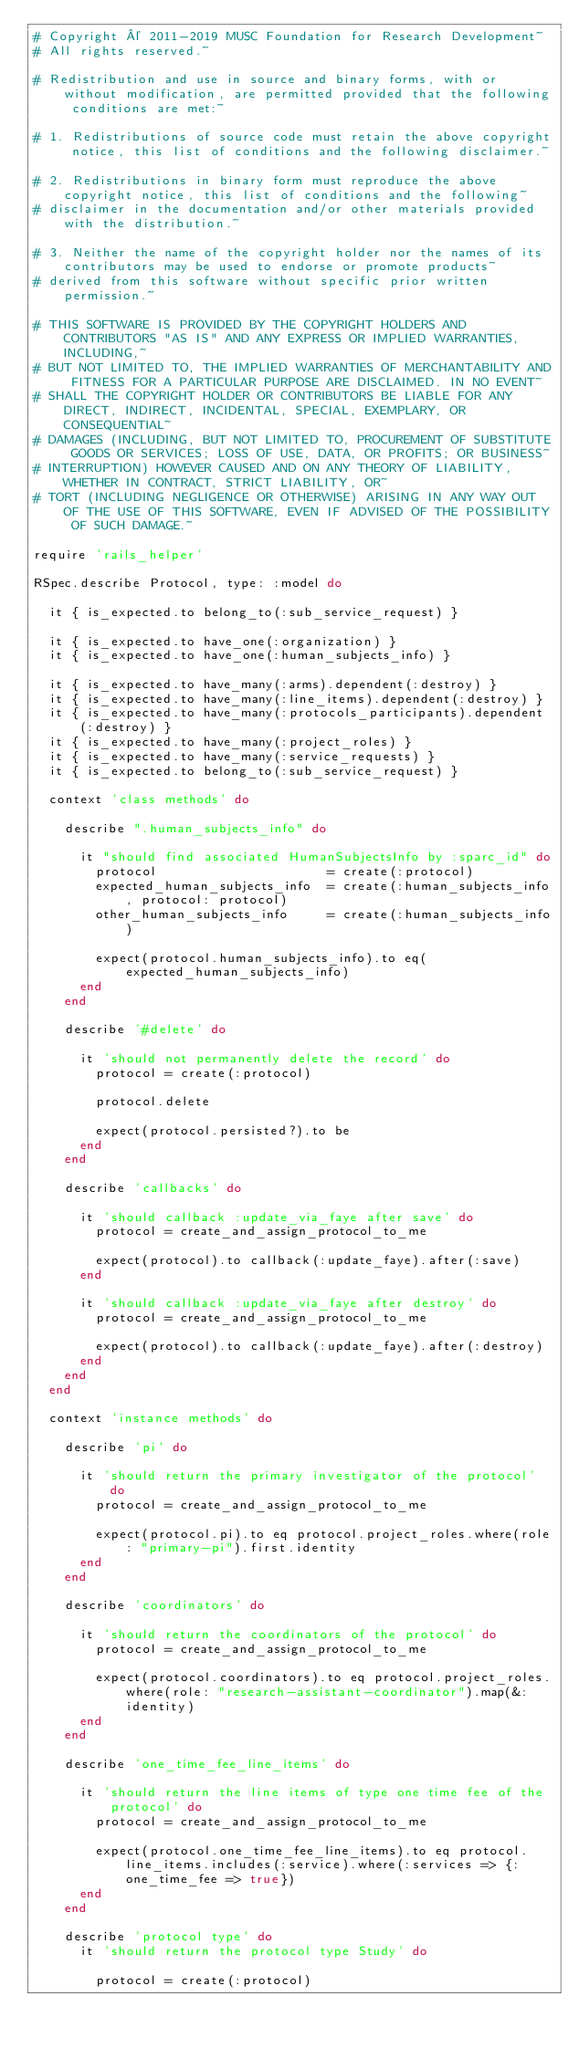<code> <loc_0><loc_0><loc_500><loc_500><_Ruby_># Copyright © 2011-2019 MUSC Foundation for Research Development~
# All rights reserved.~

# Redistribution and use in source and binary forms, with or without modification, are permitted provided that the following conditions are met:~

# 1. Redistributions of source code must retain the above copyright notice, this list of conditions and the following disclaimer.~

# 2. Redistributions in binary form must reproduce the above copyright notice, this list of conditions and the following~
# disclaimer in the documentation and/or other materials provided with the distribution.~

# 3. Neither the name of the copyright holder nor the names of its contributors may be used to endorse or promote products~
# derived from this software without specific prior written permission.~

# THIS SOFTWARE IS PROVIDED BY THE COPYRIGHT HOLDERS AND CONTRIBUTORS "AS IS" AND ANY EXPRESS OR IMPLIED WARRANTIES, INCLUDING,~
# BUT NOT LIMITED TO, THE IMPLIED WARRANTIES OF MERCHANTABILITY AND FITNESS FOR A PARTICULAR PURPOSE ARE DISCLAIMED. IN NO EVENT~
# SHALL THE COPYRIGHT HOLDER OR CONTRIBUTORS BE LIABLE FOR ANY DIRECT, INDIRECT, INCIDENTAL, SPECIAL, EXEMPLARY, OR CONSEQUENTIAL~
# DAMAGES (INCLUDING, BUT NOT LIMITED TO, PROCUREMENT OF SUBSTITUTE GOODS OR SERVICES; LOSS OF USE, DATA, OR PROFITS; OR BUSINESS~
# INTERRUPTION) HOWEVER CAUSED AND ON ANY THEORY OF LIABILITY, WHETHER IN CONTRACT, STRICT LIABILITY, OR~
# TORT (INCLUDING NEGLIGENCE OR OTHERWISE) ARISING IN ANY WAY OUT OF THE USE OF THIS SOFTWARE, EVEN IF ADVISED OF THE POSSIBILITY OF SUCH DAMAGE.~

require 'rails_helper'

RSpec.describe Protocol, type: :model do

  it { is_expected.to belong_to(:sub_service_request) }

  it { is_expected.to have_one(:organization) }
  it { is_expected.to have_one(:human_subjects_info) }

  it { is_expected.to have_many(:arms).dependent(:destroy) }
  it { is_expected.to have_many(:line_items).dependent(:destroy) }
  it { is_expected.to have_many(:protocols_participants).dependent(:destroy) }
  it { is_expected.to have_many(:project_roles) }
  it { is_expected.to have_many(:service_requests) }
  it { is_expected.to belong_to(:sub_service_request) }

  context 'class methods' do

    describe ".human_subjects_info" do

      it "should find associated HumanSubjectsInfo by :sparc_id" do
        protocol                      = create(:protocol)
        expected_human_subjects_info  = create(:human_subjects_info, protocol: protocol)
        other_human_subjects_info     = create(:human_subjects_info)

        expect(protocol.human_subjects_info).to eq(expected_human_subjects_info)
      end
    end

    describe '#delete' do

      it 'should not permanently delete the record' do
        protocol = create(:protocol)

        protocol.delete

        expect(protocol.persisted?).to be
      end
    end

    describe 'callbacks' do

      it 'should callback :update_via_faye after save' do
        protocol = create_and_assign_protocol_to_me

        expect(protocol).to callback(:update_faye).after(:save)
      end

      it 'should callback :update_via_faye after destroy' do
        protocol = create_and_assign_protocol_to_me

        expect(protocol).to callback(:update_faye).after(:destroy)
      end
    end
  end

  context 'instance methods' do

    describe 'pi' do

      it 'should return the primary investigator of the protocol' do
        protocol = create_and_assign_protocol_to_me

        expect(protocol.pi).to eq protocol.project_roles.where(role: "primary-pi").first.identity
      end
    end

    describe 'coordinators' do

      it 'should return the coordinators of the protocol' do
        protocol = create_and_assign_protocol_to_me

        expect(protocol.coordinators).to eq protocol.project_roles.where(role: "research-assistant-coordinator").map(&:identity)
      end
    end

    describe 'one_time_fee_line_items' do

      it 'should return the line items of type one time fee of the protocol' do
        protocol = create_and_assign_protocol_to_me

        expect(protocol.one_time_fee_line_items).to eq protocol.line_items.includes(:service).where(:services => {:one_time_fee => true})
      end
    end

    describe 'protocol type' do
      it 'should return the protocol type Study' do
        
        protocol = create(:protocol)</code> 